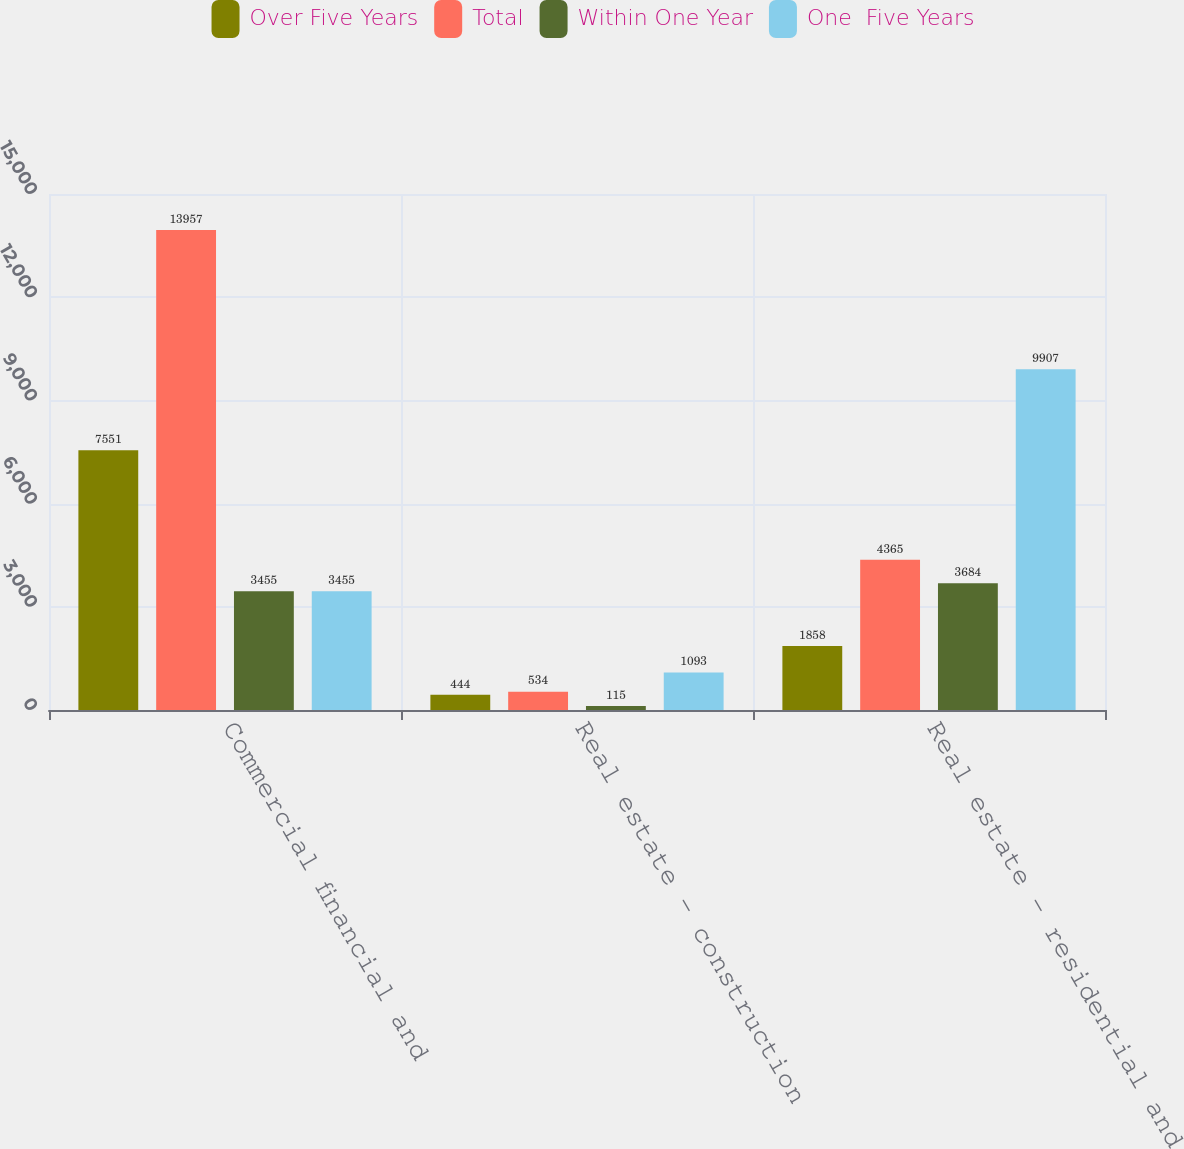Convert chart to OTSL. <chart><loc_0><loc_0><loc_500><loc_500><stacked_bar_chart><ecel><fcel>Commercial financial and<fcel>Real estate - construction<fcel>Real estate - residential and<nl><fcel>Over Five Years<fcel>7551<fcel>444<fcel>1858<nl><fcel>Total<fcel>13957<fcel>534<fcel>4365<nl><fcel>Within One Year<fcel>3455<fcel>115<fcel>3684<nl><fcel>One  Five Years<fcel>3455<fcel>1093<fcel>9907<nl></chart> 